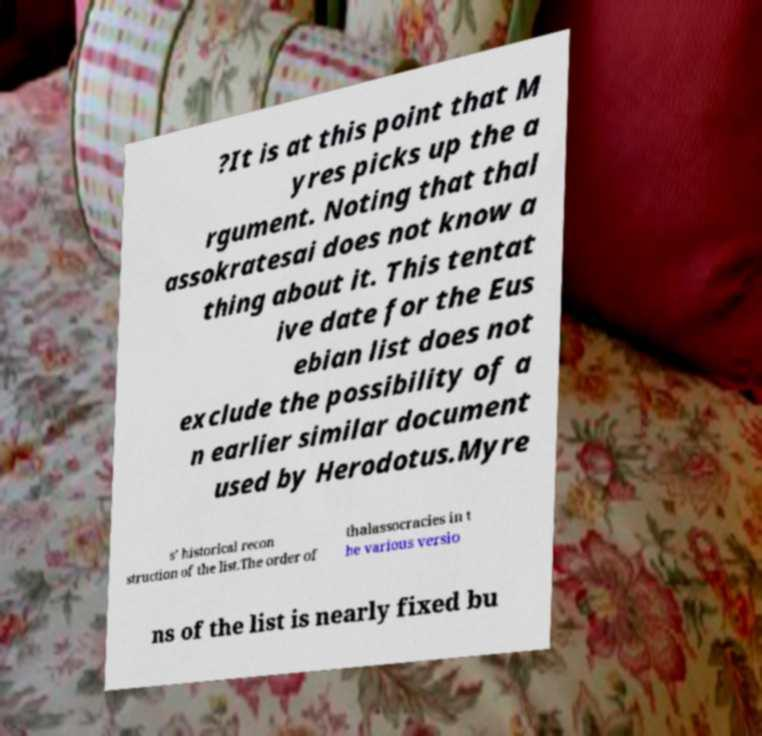Can you read and provide the text displayed in the image?This photo seems to have some interesting text. Can you extract and type it out for me? ?It is at this point that M yres picks up the a rgument. Noting that thal assokratesai does not know a thing about it. This tentat ive date for the Eus ebian list does not exclude the possibility of a n earlier similar document used by Herodotus.Myre s’ historical recon struction of the list.The order of thalassocracies in t he various versio ns of the list is nearly fixed bu 